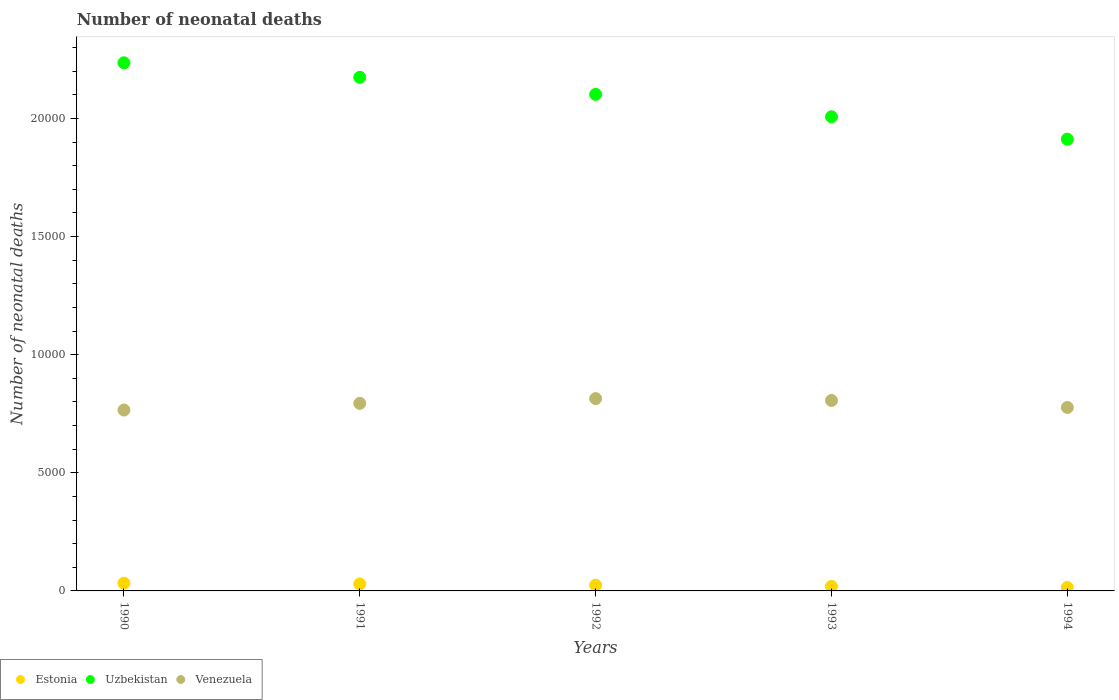Is the number of dotlines equal to the number of legend labels?
Make the answer very short. Yes. What is the number of neonatal deaths in in Uzbekistan in 1991?
Your answer should be compact. 2.17e+04. Across all years, what is the maximum number of neonatal deaths in in Venezuela?
Provide a succinct answer. 8141. Across all years, what is the minimum number of neonatal deaths in in Estonia?
Keep it short and to the point. 148. In which year was the number of neonatal deaths in in Venezuela minimum?
Give a very brief answer. 1990. What is the total number of neonatal deaths in in Estonia in the graph?
Make the answer very short. 1209. What is the difference between the number of neonatal deaths in in Venezuela in 1993 and that in 1994?
Give a very brief answer. 296. What is the difference between the number of neonatal deaths in in Uzbekistan in 1993 and the number of neonatal deaths in in Venezuela in 1990?
Your response must be concise. 1.24e+04. What is the average number of neonatal deaths in in Venezuela per year?
Give a very brief answer. 7913. In the year 1991, what is the difference between the number of neonatal deaths in in Uzbekistan and number of neonatal deaths in in Estonia?
Keep it short and to the point. 2.14e+04. What is the ratio of the number of neonatal deaths in in Venezuela in 1990 to that in 1992?
Provide a short and direct response. 0.94. Is the number of neonatal deaths in in Estonia in 1992 less than that in 1994?
Ensure brevity in your answer.  No. What is the difference between the highest and the second highest number of neonatal deaths in in Venezuela?
Keep it short and to the point. 79. What is the difference between the highest and the lowest number of neonatal deaths in in Estonia?
Ensure brevity in your answer.  183. Is the sum of the number of neonatal deaths in in Estonia in 1991 and 1993 greater than the maximum number of neonatal deaths in in Uzbekistan across all years?
Your answer should be compact. No. Is it the case that in every year, the sum of the number of neonatal deaths in in Estonia and number of neonatal deaths in in Uzbekistan  is greater than the number of neonatal deaths in in Venezuela?
Make the answer very short. Yes. Is the number of neonatal deaths in in Estonia strictly less than the number of neonatal deaths in in Venezuela over the years?
Keep it short and to the point. Yes. How many years are there in the graph?
Give a very brief answer. 5. Are the values on the major ticks of Y-axis written in scientific E-notation?
Your answer should be compact. No. Does the graph contain grids?
Your answer should be very brief. No. Where does the legend appear in the graph?
Offer a very short reply. Bottom left. How many legend labels are there?
Your answer should be compact. 3. What is the title of the graph?
Your answer should be very brief. Number of neonatal deaths. Does "Latvia" appear as one of the legend labels in the graph?
Make the answer very short. No. What is the label or title of the Y-axis?
Your answer should be very brief. Number of neonatal deaths. What is the Number of neonatal deaths in Estonia in 1990?
Offer a terse response. 331. What is the Number of neonatal deaths in Uzbekistan in 1990?
Ensure brevity in your answer.  2.24e+04. What is the Number of neonatal deaths in Venezuela in 1990?
Ensure brevity in your answer.  7657. What is the Number of neonatal deaths in Estonia in 1991?
Your response must be concise. 294. What is the Number of neonatal deaths of Uzbekistan in 1991?
Provide a short and direct response. 2.17e+04. What is the Number of neonatal deaths in Venezuela in 1991?
Provide a short and direct response. 7939. What is the Number of neonatal deaths of Estonia in 1992?
Your answer should be very brief. 244. What is the Number of neonatal deaths of Uzbekistan in 1992?
Keep it short and to the point. 2.10e+04. What is the Number of neonatal deaths in Venezuela in 1992?
Ensure brevity in your answer.  8141. What is the Number of neonatal deaths in Estonia in 1993?
Provide a succinct answer. 192. What is the Number of neonatal deaths of Uzbekistan in 1993?
Offer a very short reply. 2.01e+04. What is the Number of neonatal deaths of Venezuela in 1993?
Your answer should be very brief. 8062. What is the Number of neonatal deaths of Estonia in 1994?
Your answer should be compact. 148. What is the Number of neonatal deaths in Uzbekistan in 1994?
Ensure brevity in your answer.  1.91e+04. What is the Number of neonatal deaths of Venezuela in 1994?
Keep it short and to the point. 7766. Across all years, what is the maximum Number of neonatal deaths of Estonia?
Ensure brevity in your answer.  331. Across all years, what is the maximum Number of neonatal deaths of Uzbekistan?
Your answer should be compact. 2.24e+04. Across all years, what is the maximum Number of neonatal deaths in Venezuela?
Your answer should be very brief. 8141. Across all years, what is the minimum Number of neonatal deaths of Estonia?
Provide a succinct answer. 148. Across all years, what is the minimum Number of neonatal deaths in Uzbekistan?
Offer a very short reply. 1.91e+04. Across all years, what is the minimum Number of neonatal deaths of Venezuela?
Your response must be concise. 7657. What is the total Number of neonatal deaths in Estonia in the graph?
Offer a terse response. 1209. What is the total Number of neonatal deaths in Uzbekistan in the graph?
Your response must be concise. 1.04e+05. What is the total Number of neonatal deaths in Venezuela in the graph?
Make the answer very short. 3.96e+04. What is the difference between the Number of neonatal deaths of Uzbekistan in 1990 and that in 1991?
Provide a succinct answer. 613. What is the difference between the Number of neonatal deaths in Venezuela in 1990 and that in 1991?
Give a very brief answer. -282. What is the difference between the Number of neonatal deaths in Uzbekistan in 1990 and that in 1992?
Your answer should be very brief. 1336. What is the difference between the Number of neonatal deaths of Venezuela in 1990 and that in 1992?
Your response must be concise. -484. What is the difference between the Number of neonatal deaths of Estonia in 1990 and that in 1993?
Give a very brief answer. 139. What is the difference between the Number of neonatal deaths of Uzbekistan in 1990 and that in 1993?
Your answer should be very brief. 2284. What is the difference between the Number of neonatal deaths of Venezuela in 1990 and that in 1993?
Ensure brevity in your answer.  -405. What is the difference between the Number of neonatal deaths of Estonia in 1990 and that in 1994?
Ensure brevity in your answer.  183. What is the difference between the Number of neonatal deaths of Uzbekistan in 1990 and that in 1994?
Your answer should be compact. 3232. What is the difference between the Number of neonatal deaths in Venezuela in 1990 and that in 1994?
Provide a succinct answer. -109. What is the difference between the Number of neonatal deaths of Estonia in 1991 and that in 1992?
Keep it short and to the point. 50. What is the difference between the Number of neonatal deaths in Uzbekistan in 1991 and that in 1992?
Ensure brevity in your answer.  723. What is the difference between the Number of neonatal deaths in Venezuela in 1991 and that in 1992?
Provide a succinct answer. -202. What is the difference between the Number of neonatal deaths of Estonia in 1991 and that in 1993?
Offer a very short reply. 102. What is the difference between the Number of neonatal deaths of Uzbekistan in 1991 and that in 1993?
Your response must be concise. 1671. What is the difference between the Number of neonatal deaths of Venezuela in 1991 and that in 1993?
Keep it short and to the point. -123. What is the difference between the Number of neonatal deaths of Estonia in 1991 and that in 1994?
Give a very brief answer. 146. What is the difference between the Number of neonatal deaths in Uzbekistan in 1991 and that in 1994?
Provide a short and direct response. 2619. What is the difference between the Number of neonatal deaths of Venezuela in 1991 and that in 1994?
Offer a very short reply. 173. What is the difference between the Number of neonatal deaths in Estonia in 1992 and that in 1993?
Make the answer very short. 52. What is the difference between the Number of neonatal deaths of Uzbekistan in 1992 and that in 1993?
Keep it short and to the point. 948. What is the difference between the Number of neonatal deaths of Venezuela in 1992 and that in 1993?
Provide a short and direct response. 79. What is the difference between the Number of neonatal deaths of Estonia in 1992 and that in 1994?
Offer a terse response. 96. What is the difference between the Number of neonatal deaths in Uzbekistan in 1992 and that in 1994?
Provide a succinct answer. 1896. What is the difference between the Number of neonatal deaths in Venezuela in 1992 and that in 1994?
Your answer should be compact. 375. What is the difference between the Number of neonatal deaths of Uzbekistan in 1993 and that in 1994?
Your response must be concise. 948. What is the difference between the Number of neonatal deaths in Venezuela in 1993 and that in 1994?
Give a very brief answer. 296. What is the difference between the Number of neonatal deaths in Estonia in 1990 and the Number of neonatal deaths in Uzbekistan in 1991?
Your answer should be compact. -2.14e+04. What is the difference between the Number of neonatal deaths of Estonia in 1990 and the Number of neonatal deaths of Venezuela in 1991?
Your answer should be very brief. -7608. What is the difference between the Number of neonatal deaths of Uzbekistan in 1990 and the Number of neonatal deaths of Venezuela in 1991?
Your response must be concise. 1.44e+04. What is the difference between the Number of neonatal deaths of Estonia in 1990 and the Number of neonatal deaths of Uzbekistan in 1992?
Make the answer very short. -2.07e+04. What is the difference between the Number of neonatal deaths of Estonia in 1990 and the Number of neonatal deaths of Venezuela in 1992?
Your answer should be very brief. -7810. What is the difference between the Number of neonatal deaths of Uzbekistan in 1990 and the Number of neonatal deaths of Venezuela in 1992?
Your answer should be compact. 1.42e+04. What is the difference between the Number of neonatal deaths in Estonia in 1990 and the Number of neonatal deaths in Uzbekistan in 1993?
Make the answer very short. -1.97e+04. What is the difference between the Number of neonatal deaths of Estonia in 1990 and the Number of neonatal deaths of Venezuela in 1993?
Your response must be concise. -7731. What is the difference between the Number of neonatal deaths of Uzbekistan in 1990 and the Number of neonatal deaths of Venezuela in 1993?
Provide a succinct answer. 1.43e+04. What is the difference between the Number of neonatal deaths in Estonia in 1990 and the Number of neonatal deaths in Uzbekistan in 1994?
Give a very brief answer. -1.88e+04. What is the difference between the Number of neonatal deaths in Estonia in 1990 and the Number of neonatal deaths in Venezuela in 1994?
Provide a short and direct response. -7435. What is the difference between the Number of neonatal deaths of Uzbekistan in 1990 and the Number of neonatal deaths of Venezuela in 1994?
Give a very brief answer. 1.46e+04. What is the difference between the Number of neonatal deaths of Estonia in 1991 and the Number of neonatal deaths of Uzbekistan in 1992?
Ensure brevity in your answer.  -2.07e+04. What is the difference between the Number of neonatal deaths of Estonia in 1991 and the Number of neonatal deaths of Venezuela in 1992?
Your answer should be compact. -7847. What is the difference between the Number of neonatal deaths in Uzbekistan in 1991 and the Number of neonatal deaths in Venezuela in 1992?
Offer a very short reply. 1.36e+04. What is the difference between the Number of neonatal deaths in Estonia in 1991 and the Number of neonatal deaths in Uzbekistan in 1993?
Provide a succinct answer. -1.98e+04. What is the difference between the Number of neonatal deaths in Estonia in 1991 and the Number of neonatal deaths in Venezuela in 1993?
Your answer should be very brief. -7768. What is the difference between the Number of neonatal deaths of Uzbekistan in 1991 and the Number of neonatal deaths of Venezuela in 1993?
Your answer should be compact. 1.37e+04. What is the difference between the Number of neonatal deaths of Estonia in 1991 and the Number of neonatal deaths of Uzbekistan in 1994?
Provide a succinct answer. -1.88e+04. What is the difference between the Number of neonatal deaths of Estonia in 1991 and the Number of neonatal deaths of Venezuela in 1994?
Provide a short and direct response. -7472. What is the difference between the Number of neonatal deaths of Uzbekistan in 1991 and the Number of neonatal deaths of Venezuela in 1994?
Provide a succinct answer. 1.40e+04. What is the difference between the Number of neonatal deaths in Estonia in 1992 and the Number of neonatal deaths in Uzbekistan in 1993?
Offer a terse response. -1.98e+04. What is the difference between the Number of neonatal deaths in Estonia in 1992 and the Number of neonatal deaths in Venezuela in 1993?
Ensure brevity in your answer.  -7818. What is the difference between the Number of neonatal deaths of Uzbekistan in 1992 and the Number of neonatal deaths of Venezuela in 1993?
Your answer should be very brief. 1.30e+04. What is the difference between the Number of neonatal deaths in Estonia in 1992 and the Number of neonatal deaths in Uzbekistan in 1994?
Keep it short and to the point. -1.89e+04. What is the difference between the Number of neonatal deaths of Estonia in 1992 and the Number of neonatal deaths of Venezuela in 1994?
Ensure brevity in your answer.  -7522. What is the difference between the Number of neonatal deaths in Uzbekistan in 1992 and the Number of neonatal deaths in Venezuela in 1994?
Your response must be concise. 1.33e+04. What is the difference between the Number of neonatal deaths of Estonia in 1993 and the Number of neonatal deaths of Uzbekistan in 1994?
Your response must be concise. -1.89e+04. What is the difference between the Number of neonatal deaths of Estonia in 1993 and the Number of neonatal deaths of Venezuela in 1994?
Provide a succinct answer. -7574. What is the difference between the Number of neonatal deaths of Uzbekistan in 1993 and the Number of neonatal deaths of Venezuela in 1994?
Provide a short and direct response. 1.23e+04. What is the average Number of neonatal deaths of Estonia per year?
Give a very brief answer. 241.8. What is the average Number of neonatal deaths of Uzbekistan per year?
Your answer should be compact. 2.09e+04. What is the average Number of neonatal deaths of Venezuela per year?
Provide a succinct answer. 7913. In the year 1990, what is the difference between the Number of neonatal deaths of Estonia and Number of neonatal deaths of Uzbekistan?
Your response must be concise. -2.20e+04. In the year 1990, what is the difference between the Number of neonatal deaths of Estonia and Number of neonatal deaths of Venezuela?
Make the answer very short. -7326. In the year 1990, what is the difference between the Number of neonatal deaths in Uzbekistan and Number of neonatal deaths in Venezuela?
Make the answer very short. 1.47e+04. In the year 1991, what is the difference between the Number of neonatal deaths in Estonia and Number of neonatal deaths in Uzbekistan?
Offer a terse response. -2.14e+04. In the year 1991, what is the difference between the Number of neonatal deaths in Estonia and Number of neonatal deaths in Venezuela?
Make the answer very short. -7645. In the year 1991, what is the difference between the Number of neonatal deaths of Uzbekistan and Number of neonatal deaths of Venezuela?
Provide a succinct answer. 1.38e+04. In the year 1992, what is the difference between the Number of neonatal deaths of Estonia and Number of neonatal deaths of Uzbekistan?
Ensure brevity in your answer.  -2.08e+04. In the year 1992, what is the difference between the Number of neonatal deaths in Estonia and Number of neonatal deaths in Venezuela?
Your answer should be compact. -7897. In the year 1992, what is the difference between the Number of neonatal deaths of Uzbekistan and Number of neonatal deaths of Venezuela?
Keep it short and to the point. 1.29e+04. In the year 1993, what is the difference between the Number of neonatal deaths in Estonia and Number of neonatal deaths in Uzbekistan?
Ensure brevity in your answer.  -1.99e+04. In the year 1993, what is the difference between the Number of neonatal deaths of Estonia and Number of neonatal deaths of Venezuela?
Your answer should be compact. -7870. In the year 1993, what is the difference between the Number of neonatal deaths of Uzbekistan and Number of neonatal deaths of Venezuela?
Your answer should be compact. 1.20e+04. In the year 1994, what is the difference between the Number of neonatal deaths in Estonia and Number of neonatal deaths in Uzbekistan?
Give a very brief answer. -1.90e+04. In the year 1994, what is the difference between the Number of neonatal deaths in Estonia and Number of neonatal deaths in Venezuela?
Your answer should be compact. -7618. In the year 1994, what is the difference between the Number of neonatal deaths in Uzbekistan and Number of neonatal deaths in Venezuela?
Your answer should be very brief. 1.14e+04. What is the ratio of the Number of neonatal deaths in Estonia in 1990 to that in 1991?
Offer a very short reply. 1.13. What is the ratio of the Number of neonatal deaths of Uzbekistan in 1990 to that in 1991?
Give a very brief answer. 1.03. What is the ratio of the Number of neonatal deaths of Venezuela in 1990 to that in 1991?
Offer a very short reply. 0.96. What is the ratio of the Number of neonatal deaths of Estonia in 1990 to that in 1992?
Keep it short and to the point. 1.36. What is the ratio of the Number of neonatal deaths of Uzbekistan in 1990 to that in 1992?
Provide a short and direct response. 1.06. What is the ratio of the Number of neonatal deaths in Venezuela in 1990 to that in 1992?
Ensure brevity in your answer.  0.94. What is the ratio of the Number of neonatal deaths in Estonia in 1990 to that in 1993?
Your response must be concise. 1.72. What is the ratio of the Number of neonatal deaths of Uzbekistan in 1990 to that in 1993?
Ensure brevity in your answer.  1.11. What is the ratio of the Number of neonatal deaths in Venezuela in 1990 to that in 1993?
Provide a short and direct response. 0.95. What is the ratio of the Number of neonatal deaths in Estonia in 1990 to that in 1994?
Offer a terse response. 2.24. What is the ratio of the Number of neonatal deaths in Uzbekistan in 1990 to that in 1994?
Make the answer very short. 1.17. What is the ratio of the Number of neonatal deaths of Venezuela in 1990 to that in 1994?
Ensure brevity in your answer.  0.99. What is the ratio of the Number of neonatal deaths of Estonia in 1991 to that in 1992?
Your response must be concise. 1.2. What is the ratio of the Number of neonatal deaths of Uzbekistan in 1991 to that in 1992?
Offer a terse response. 1.03. What is the ratio of the Number of neonatal deaths of Venezuela in 1991 to that in 1992?
Provide a short and direct response. 0.98. What is the ratio of the Number of neonatal deaths of Estonia in 1991 to that in 1993?
Make the answer very short. 1.53. What is the ratio of the Number of neonatal deaths of Uzbekistan in 1991 to that in 1993?
Give a very brief answer. 1.08. What is the ratio of the Number of neonatal deaths of Venezuela in 1991 to that in 1993?
Your answer should be compact. 0.98. What is the ratio of the Number of neonatal deaths in Estonia in 1991 to that in 1994?
Make the answer very short. 1.99. What is the ratio of the Number of neonatal deaths in Uzbekistan in 1991 to that in 1994?
Your answer should be compact. 1.14. What is the ratio of the Number of neonatal deaths in Venezuela in 1991 to that in 1994?
Keep it short and to the point. 1.02. What is the ratio of the Number of neonatal deaths in Estonia in 1992 to that in 1993?
Make the answer very short. 1.27. What is the ratio of the Number of neonatal deaths in Uzbekistan in 1992 to that in 1993?
Give a very brief answer. 1.05. What is the ratio of the Number of neonatal deaths of Venezuela in 1992 to that in 1993?
Ensure brevity in your answer.  1.01. What is the ratio of the Number of neonatal deaths of Estonia in 1992 to that in 1994?
Offer a terse response. 1.65. What is the ratio of the Number of neonatal deaths in Uzbekistan in 1992 to that in 1994?
Your answer should be very brief. 1.1. What is the ratio of the Number of neonatal deaths in Venezuela in 1992 to that in 1994?
Your answer should be very brief. 1.05. What is the ratio of the Number of neonatal deaths of Estonia in 1993 to that in 1994?
Ensure brevity in your answer.  1.3. What is the ratio of the Number of neonatal deaths in Uzbekistan in 1993 to that in 1994?
Offer a very short reply. 1.05. What is the ratio of the Number of neonatal deaths of Venezuela in 1993 to that in 1994?
Your answer should be very brief. 1.04. What is the difference between the highest and the second highest Number of neonatal deaths in Uzbekistan?
Offer a very short reply. 613. What is the difference between the highest and the second highest Number of neonatal deaths of Venezuela?
Keep it short and to the point. 79. What is the difference between the highest and the lowest Number of neonatal deaths in Estonia?
Ensure brevity in your answer.  183. What is the difference between the highest and the lowest Number of neonatal deaths in Uzbekistan?
Make the answer very short. 3232. What is the difference between the highest and the lowest Number of neonatal deaths in Venezuela?
Your answer should be very brief. 484. 